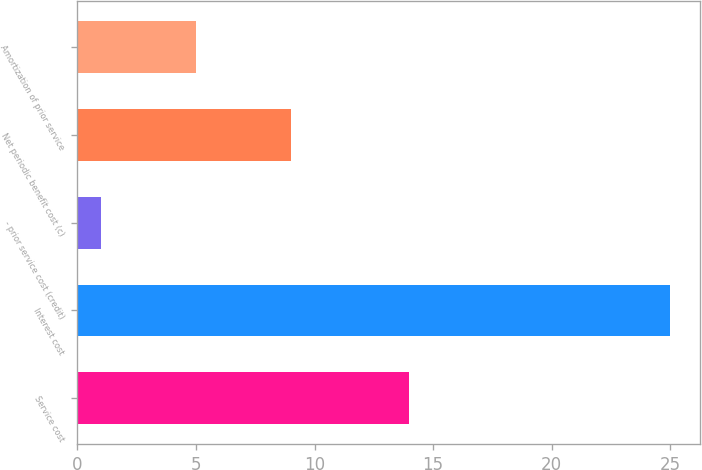Convert chart. <chart><loc_0><loc_0><loc_500><loc_500><bar_chart><fcel>Service cost<fcel>Interest cost<fcel>- prior service cost (credit)<fcel>Net periodic benefit cost (c)<fcel>Amortization of prior service<nl><fcel>14<fcel>25<fcel>1<fcel>9<fcel>5<nl></chart> 